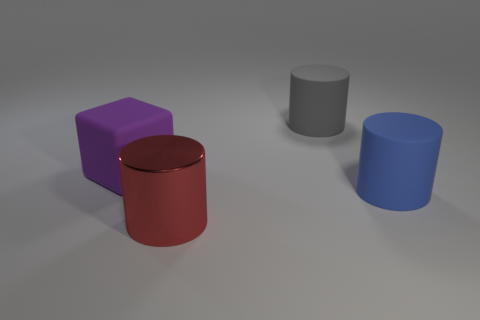Do the gray rubber cylinder and the purple object have the same size?
Your answer should be very brief. Yes. How many other objects are there of the same size as the blue matte cylinder?
Your response must be concise. 3. What number of objects are cylinders that are right of the big red metallic thing or big objects that are behind the large blue rubber cylinder?
Your answer should be compact. 3. What shape is the red shiny thing that is the same size as the gray matte thing?
Make the answer very short. Cylinder. What is the size of the gray object that is the same material as the blue cylinder?
Give a very brief answer. Large. Does the gray object have the same shape as the red thing?
Offer a terse response. Yes. What is the color of the matte block that is the same size as the red shiny object?
Offer a very short reply. Purple. There is a gray object that is the same shape as the large red metallic object; what is its size?
Keep it short and to the point. Large. What is the shape of the big thing that is in front of the big blue cylinder?
Keep it short and to the point. Cylinder. Is the shape of the blue matte object the same as the large thing in front of the large blue rubber cylinder?
Give a very brief answer. Yes. 